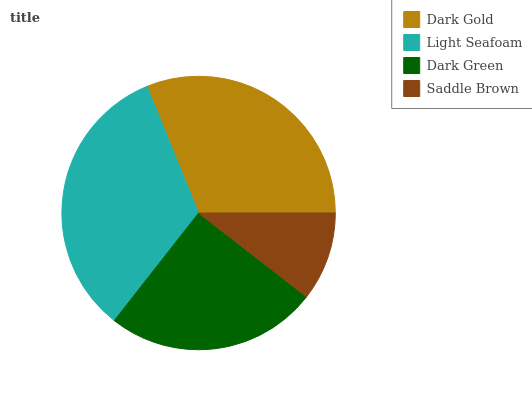Is Saddle Brown the minimum?
Answer yes or no. Yes. Is Light Seafoam the maximum?
Answer yes or no. Yes. Is Dark Green the minimum?
Answer yes or no. No. Is Dark Green the maximum?
Answer yes or no. No. Is Light Seafoam greater than Dark Green?
Answer yes or no. Yes. Is Dark Green less than Light Seafoam?
Answer yes or no. Yes. Is Dark Green greater than Light Seafoam?
Answer yes or no. No. Is Light Seafoam less than Dark Green?
Answer yes or no. No. Is Dark Gold the high median?
Answer yes or no. Yes. Is Dark Green the low median?
Answer yes or no. Yes. Is Saddle Brown the high median?
Answer yes or no. No. Is Light Seafoam the low median?
Answer yes or no. No. 